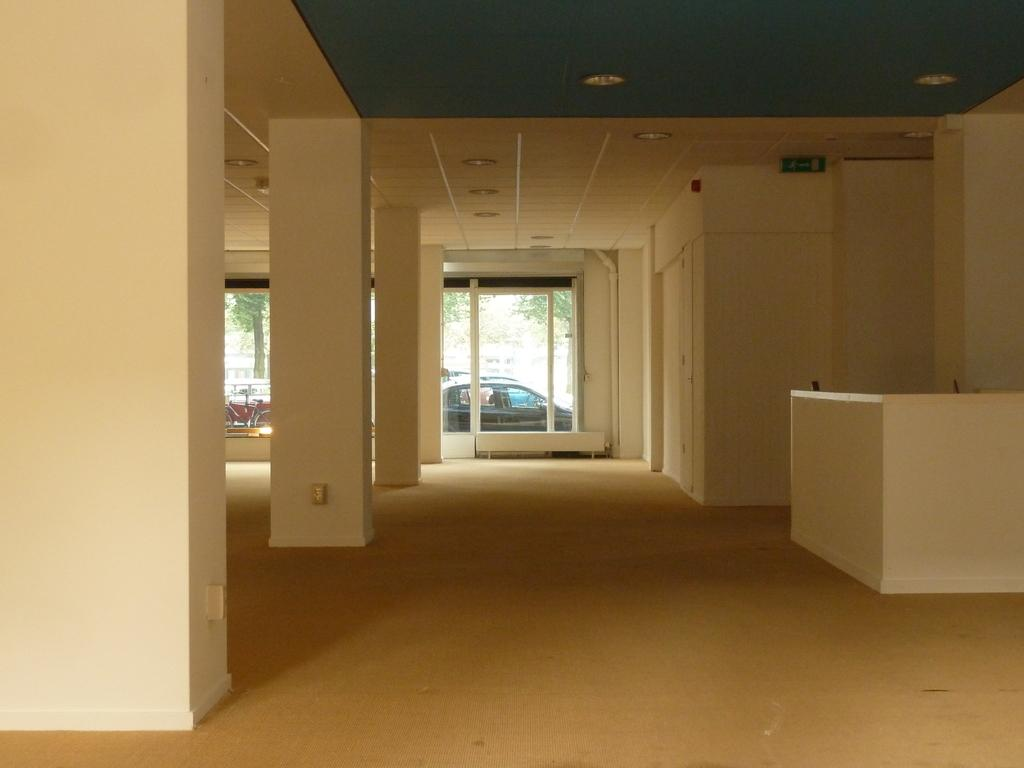What type of view does the image provide? The image provides an inside view of a building. What architectural features can be seen in the building? There are pillars in the building. What material is used for the windows in the building? There is glass in the building. What is the purpose of the board in the building? The purpose of the board is not specified in the image, but it is present in the building. What is above the space shown in the image? There is a ceiling in the building. What provides illumination in the building? There are lights in the building. What is visible on the floor in the building? The floor is visible in the building. What can be seen outside the building through the glass? A car, a bicycle, and trees can be seen outside the building through the glass. What historical event is being discussed by the passengers in the car visible through the glass? There are no passengers visible in the car, and therefore no discussion can be observed. 